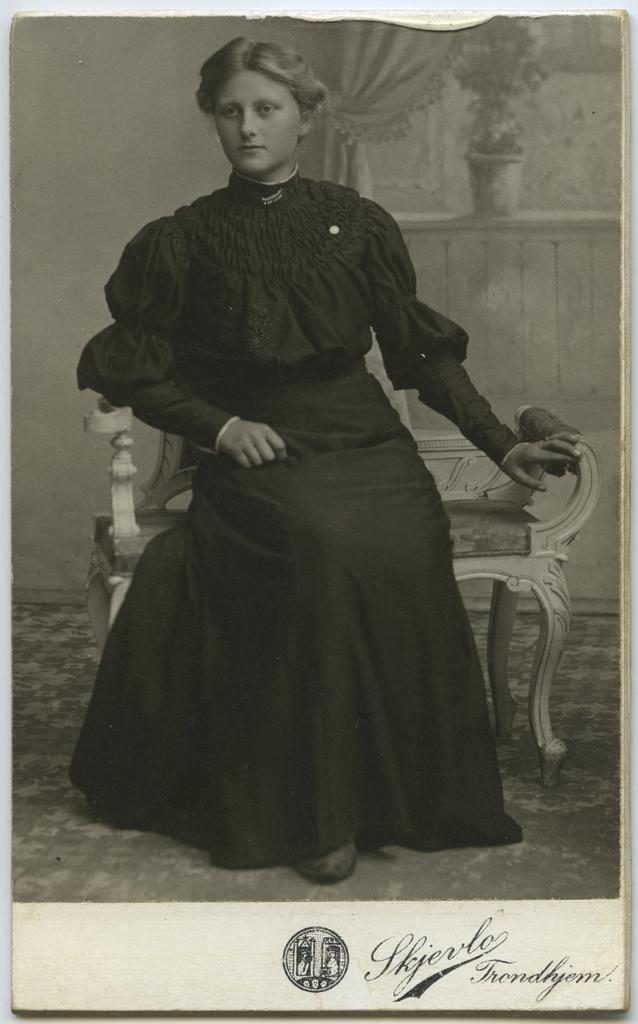In one or two sentences, can you explain what this image depicts? In this image I can see an old photograph of a woman wearing black color dress is sitting on a chair. I can see the wall, the curtain and a flower pot on the window. I can see something is written to the bottom of the image. 